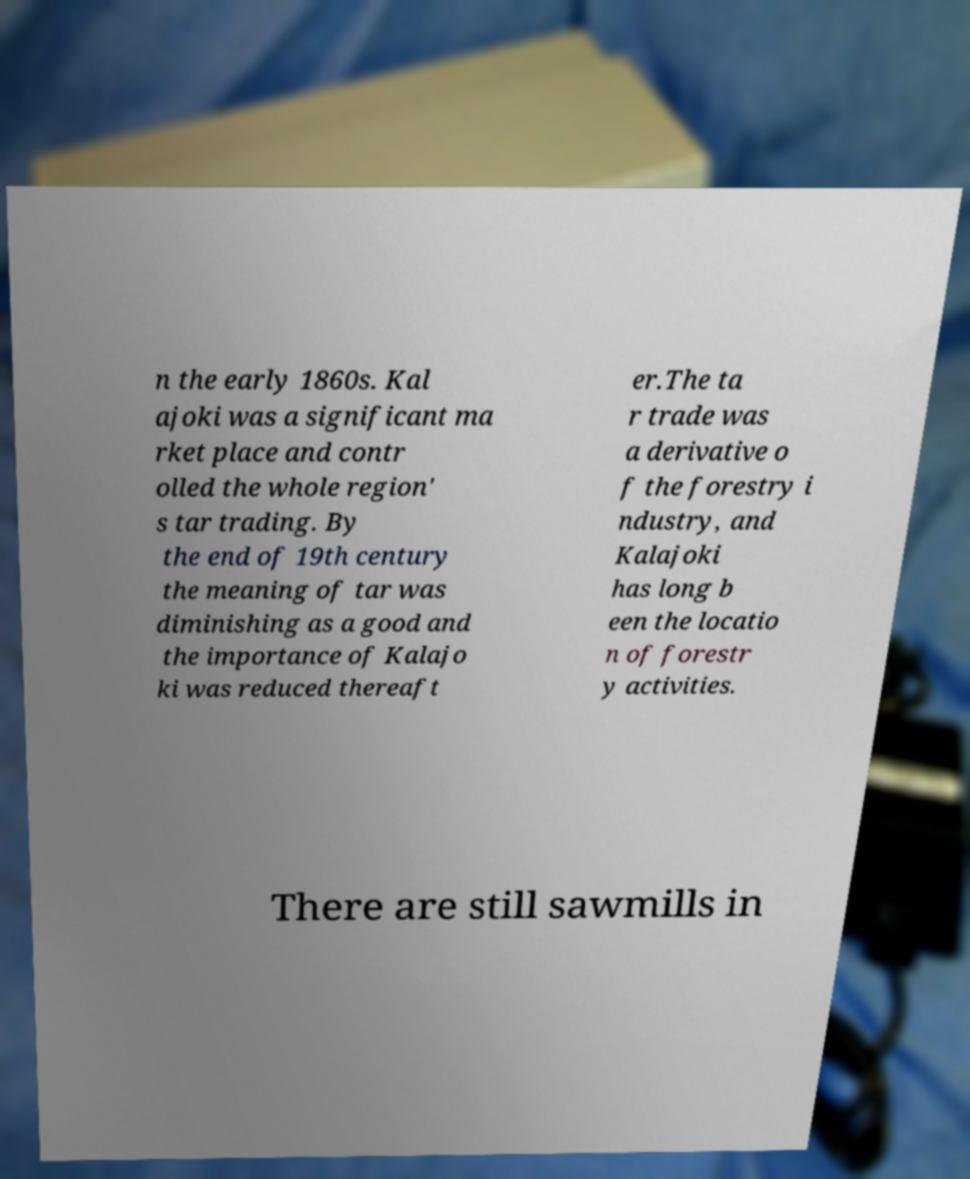I need the written content from this picture converted into text. Can you do that? n the early 1860s. Kal ajoki was a significant ma rket place and contr olled the whole region' s tar trading. By the end of 19th century the meaning of tar was diminishing as a good and the importance of Kalajo ki was reduced thereaft er.The ta r trade was a derivative o f the forestry i ndustry, and Kalajoki has long b een the locatio n of forestr y activities. There are still sawmills in 